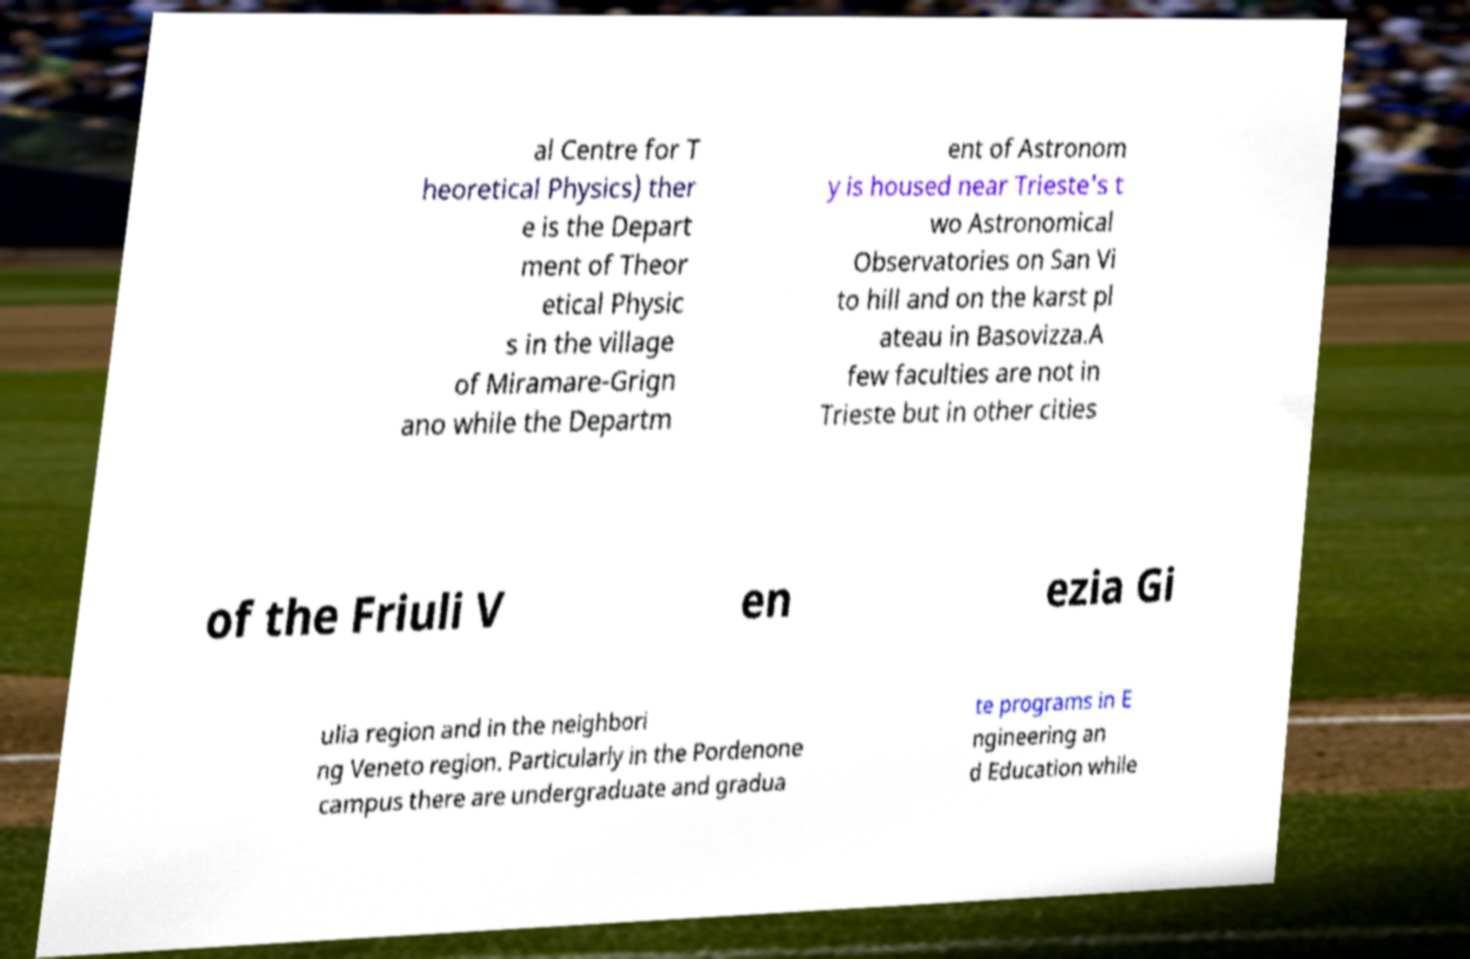Can you read and provide the text displayed in the image?This photo seems to have some interesting text. Can you extract and type it out for me? al Centre for T heoretical Physics) ther e is the Depart ment of Theor etical Physic s in the village of Miramare-Grign ano while the Departm ent of Astronom y is housed near Trieste's t wo Astronomical Observatories on San Vi to hill and on the karst pl ateau in Basovizza.A few faculties are not in Trieste but in other cities of the Friuli V en ezia Gi ulia region and in the neighbori ng Veneto region. Particularly in the Pordenone campus there are undergraduate and gradua te programs in E ngineering an d Education while 